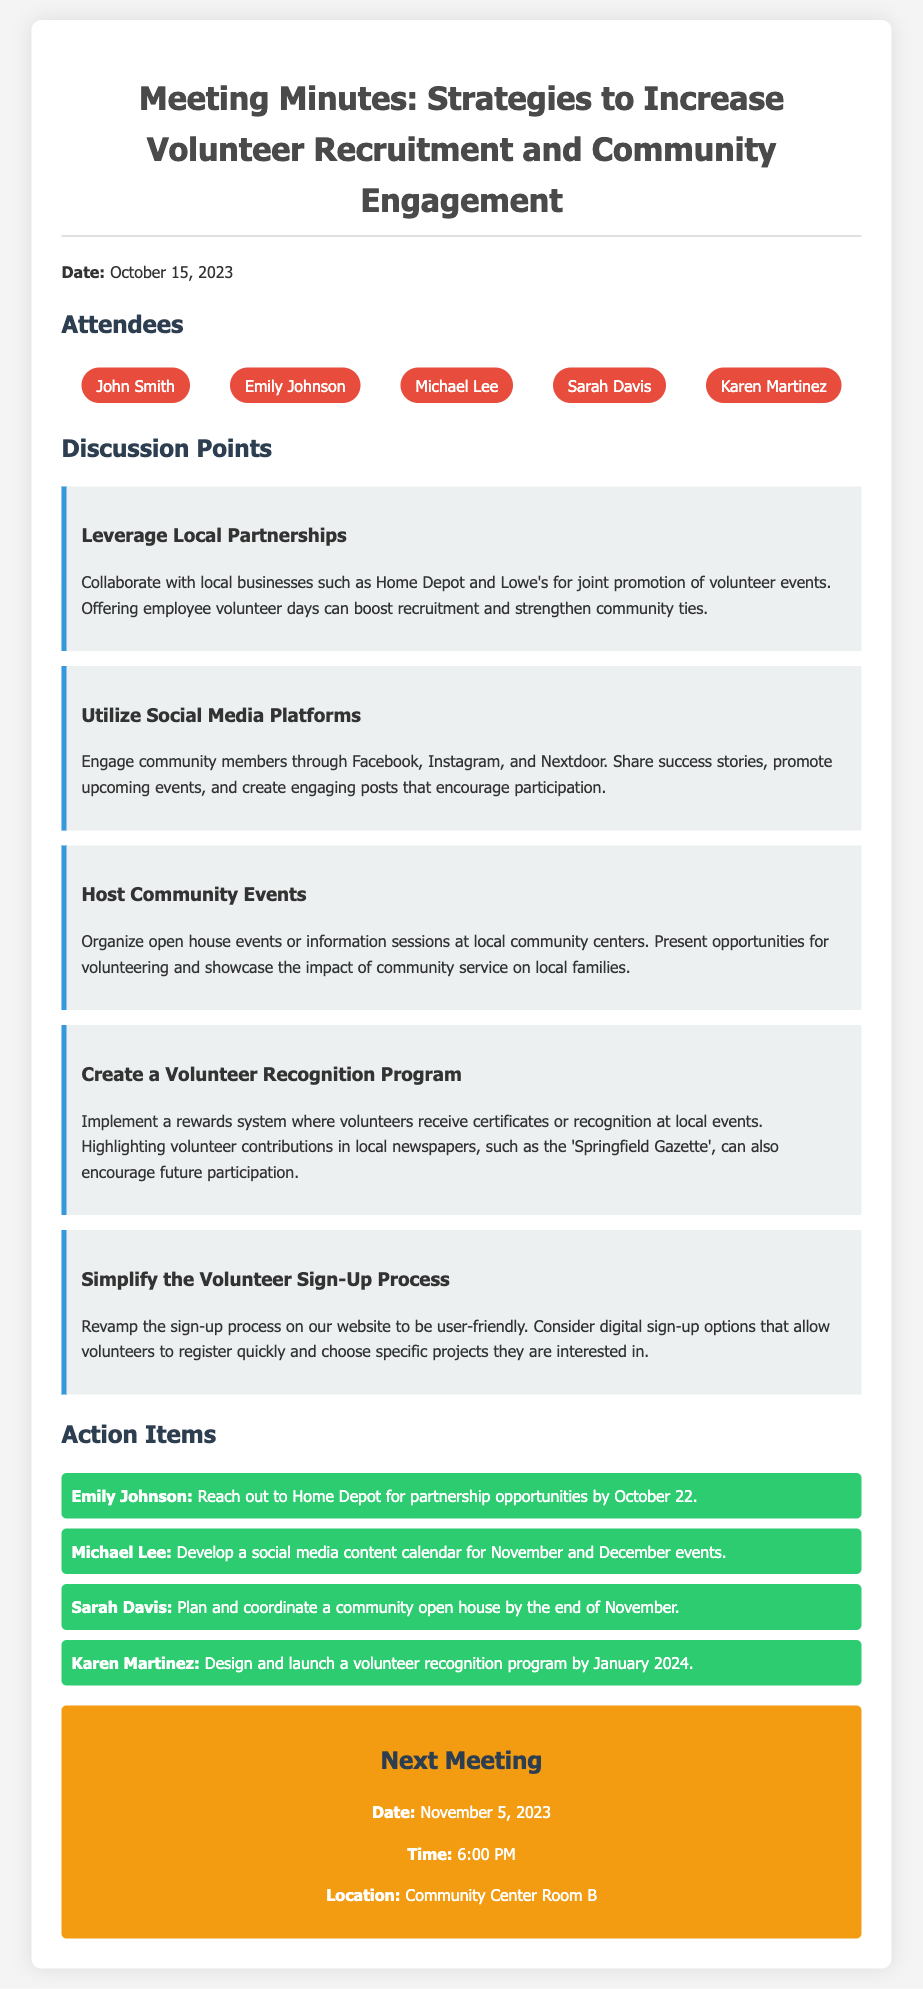What is the date of the meeting? The date of the meeting is explicitly mentioned in the document as October 15, 2023.
Answer: October 15, 2023 Who is responsible for reaching out to Home Depot? The action item indicates that Emily Johnson is tasked with reaching out to Home Depot for partnership opportunities.
Answer: Emily Johnson What is one of the suggested social media platforms for engagement? The discussion points include different social media platforms, one of which is mentioned as Facebook.
Answer: Facebook What is the proposed timeline for launching the volunteer recognition program? The document states that Karen Martinez is to design and launch the program by January 2024.
Answer: January 2024 How many attendees were present at the meeting? The list of attendees includes five individuals mentioned in the document.
Answer: Five What type of events are suggested to host for community engagement? The discussion points refer to organizing open house events or information sessions at local community centers.
Answer: Open house events What is the next meeting date? The document specifies that the next meeting is scheduled for November 5, 2023.
Answer: November 5, 2023 What method is proposed to simplify the volunteer sign-up process? The discussion includes revamping the sign-up process to be user-friendly with digital options for quick registration.
Answer: Digital sign-up options 